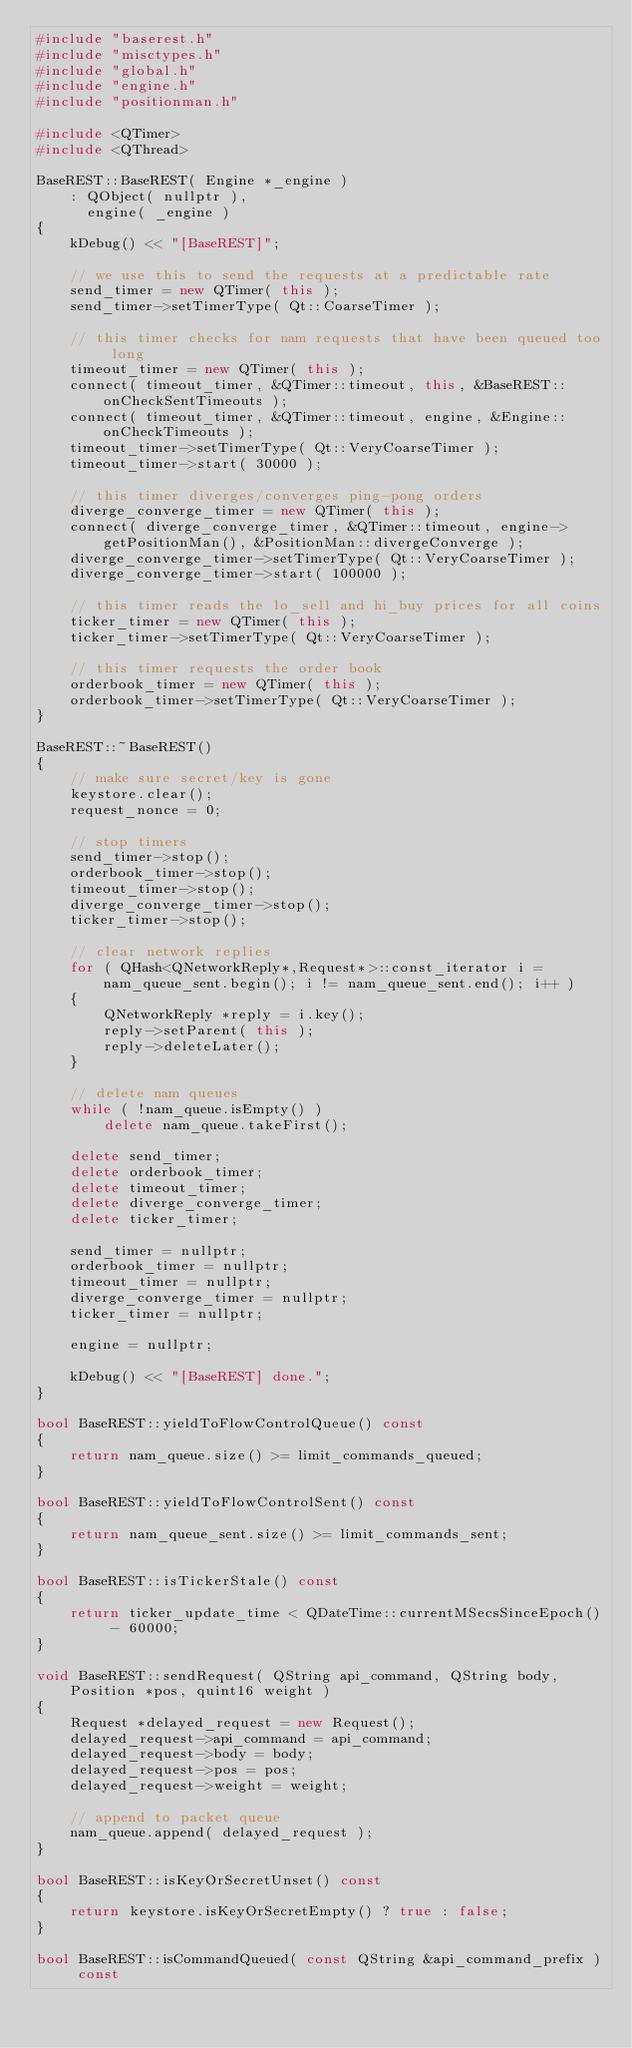Convert code to text. <code><loc_0><loc_0><loc_500><loc_500><_C++_>#include "baserest.h"
#include "misctypes.h"
#include "global.h"
#include "engine.h"
#include "positionman.h"

#include <QTimer>
#include <QThread>

BaseREST::BaseREST( Engine *_engine )
    : QObject( nullptr ),
      engine( _engine )
{
    kDebug() << "[BaseREST]";

    // we use this to send the requests at a predictable rate
    send_timer = new QTimer( this );
    send_timer->setTimerType( Qt::CoarseTimer );

    // this timer checks for nam requests that have been queued too long
    timeout_timer = new QTimer( this );
    connect( timeout_timer, &QTimer::timeout, this, &BaseREST::onCheckSentTimeouts );
    connect( timeout_timer, &QTimer::timeout, engine, &Engine::onCheckTimeouts );
    timeout_timer->setTimerType( Qt::VeryCoarseTimer );
    timeout_timer->start( 30000 );

    // this timer diverges/converges ping-pong orders
    diverge_converge_timer = new QTimer( this );
    connect( diverge_converge_timer, &QTimer::timeout, engine->getPositionMan(), &PositionMan::divergeConverge );
    diverge_converge_timer->setTimerType( Qt::VeryCoarseTimer );
    diverge_converge_timer->start( 100000 );

    // this timer reads the lo_sell and hi_buy prices for all coins
    ticker_timer = new QTimer( this );
    ticker_timer->setTimerType( Qt::VeryCoarseTimer );

    // this timer requests the order book
    orderbook_timer = new QTimer( this );
    orderbook_timer->setTimerType( Qt::VeryCoarseTimer );
}

BaseREST::~BaseREST()
{
    // make sure secret/key is gone
    keystore.clear();
    request_nonce = 0;

    // stop timers
    send_timer->stop();
    orderbook_timer->stop();
    timeout_timer->stop();
    diverge_converge_timer->stop();
    ticker_timer->stop();

    // clear network replies
    for ( QHash<QNetworkReply*,Request*>::const_iterator i = nam_queue_sent.begin(); i != nam_queue_sent.end(); i++ )
    {
        QNetworkReply *reply = i.key();
        reply->setParent( this );
        reply->deleteLater();
    }

    // delete nam queues
    while ( !nam_queue.isEmpty() )
        delete nam_queue.takeFirst();

    delete send_timer;
    delete orderbook_timer;
    delete timeout_timer;
    delete diverge_converge_timer;
    delete ticker_timer;

    send_timer = nullptr;
    orderbook_timer = nullptr;
    timeout_timer = nullptr;
    diverge_converge_timer = nullptr;
    ticker_timer = nullptr;

    engine = nullptr;

    kDebug() << "[BaseREST] done.";
}

bool BaseREST::yieldToFlowControlQueue() const
{
    return nam_queue.size() >= limit_commands_queued;
}

bool BaseREST::yieldToFlowControlSent() const
{
    return nam_queue_sent.size() >= limit_commands_sent;
}

bool BaseREST::isTickerStale() const
{
    return ticker_update_time < QDateTime::currentMSecsSinceEpoch() - 60000;
}

void BaseREST::sendRequest( QString api_command, QString body, Position *pos, quint16 weight )
{
    Request *delayed_request = new Request();
    delayed_request->api_command = api_command;
    delayed_request->body = body;
    delayed_request->pos = pos;
    delayed_request->weight = weight;

    // append to packet queue
    nam_queue.append( delayed_request );
}

bool BaseREST::isKeyOrSecretUnset() const
{
    return keystore.isKeyOrSecretEmpty() ? true : false;
}

bool BaseREST::isCommandQueued( const QString &api_command_prefix ) const</code> 